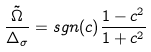<formula> <loc_0><loc_0><loc_500><loc_500>\frac { \tilde { \Omega } } { \Delta _ { \sigma } } = s g n ( c ) \frac { 1 - c ^ { 2 } } { 1 + c ^ { 2 } }</formula> 